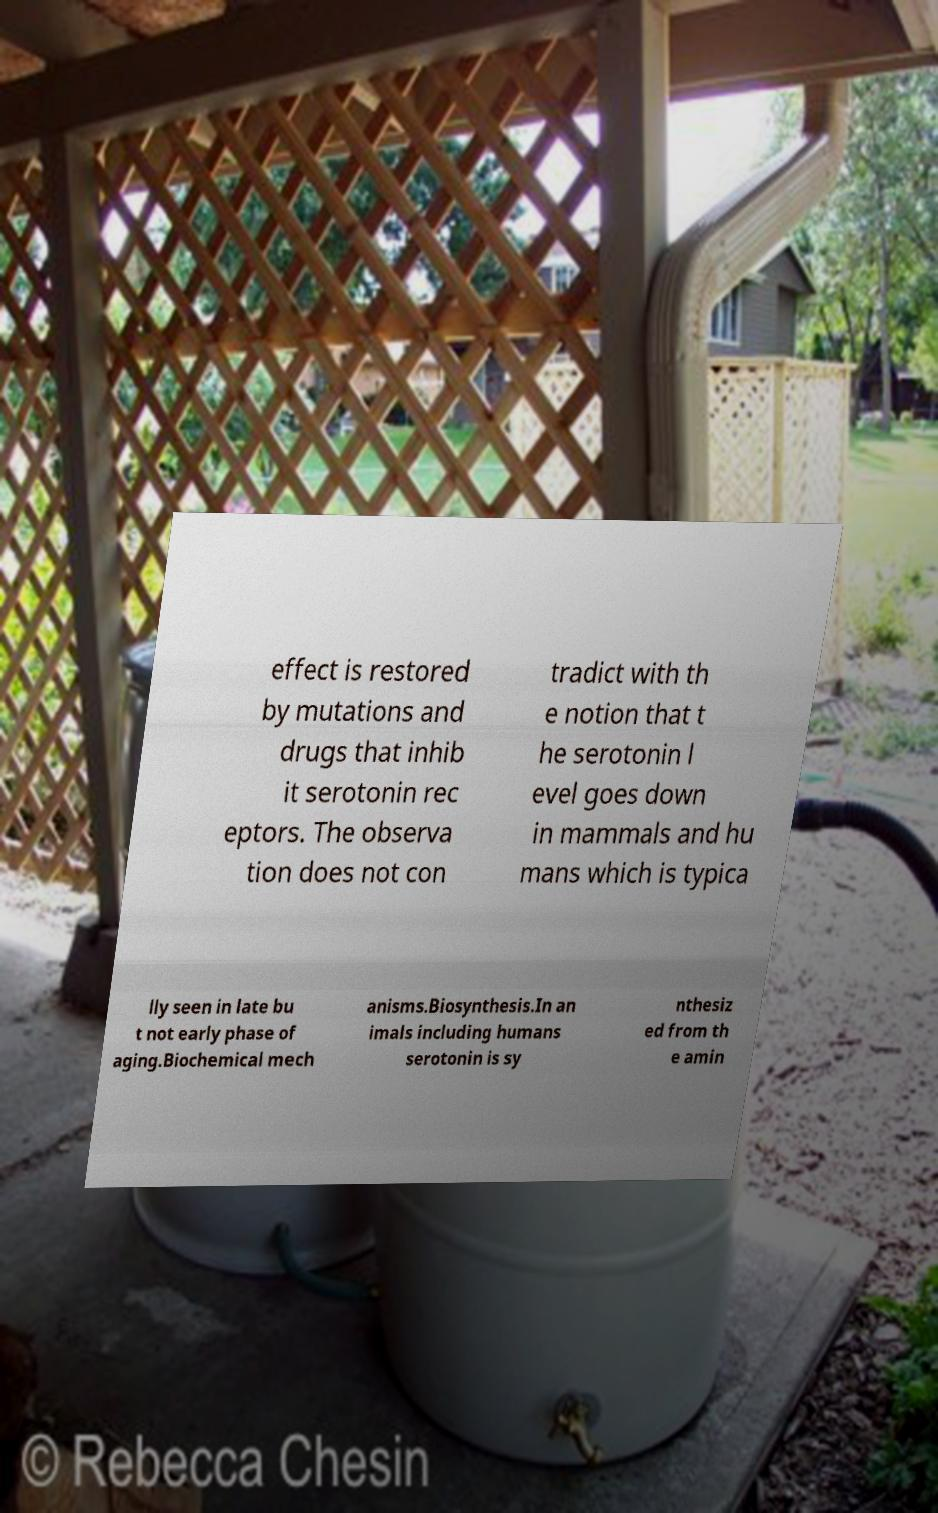Please read and relay the text visible in this image. What does it say? effect is restored by mutations and drugs that inhib it serotonin rec eptors. The observa tion does not con tradict with th e notion that t he serotonin l evel goes down in mammals and hu mans which is typica lly seen in late bu t not early phase of aging.Biochemical mech anisms.Biosynthesis.In an imals including humans serotonin is sy nthesiz ed from th e amin 